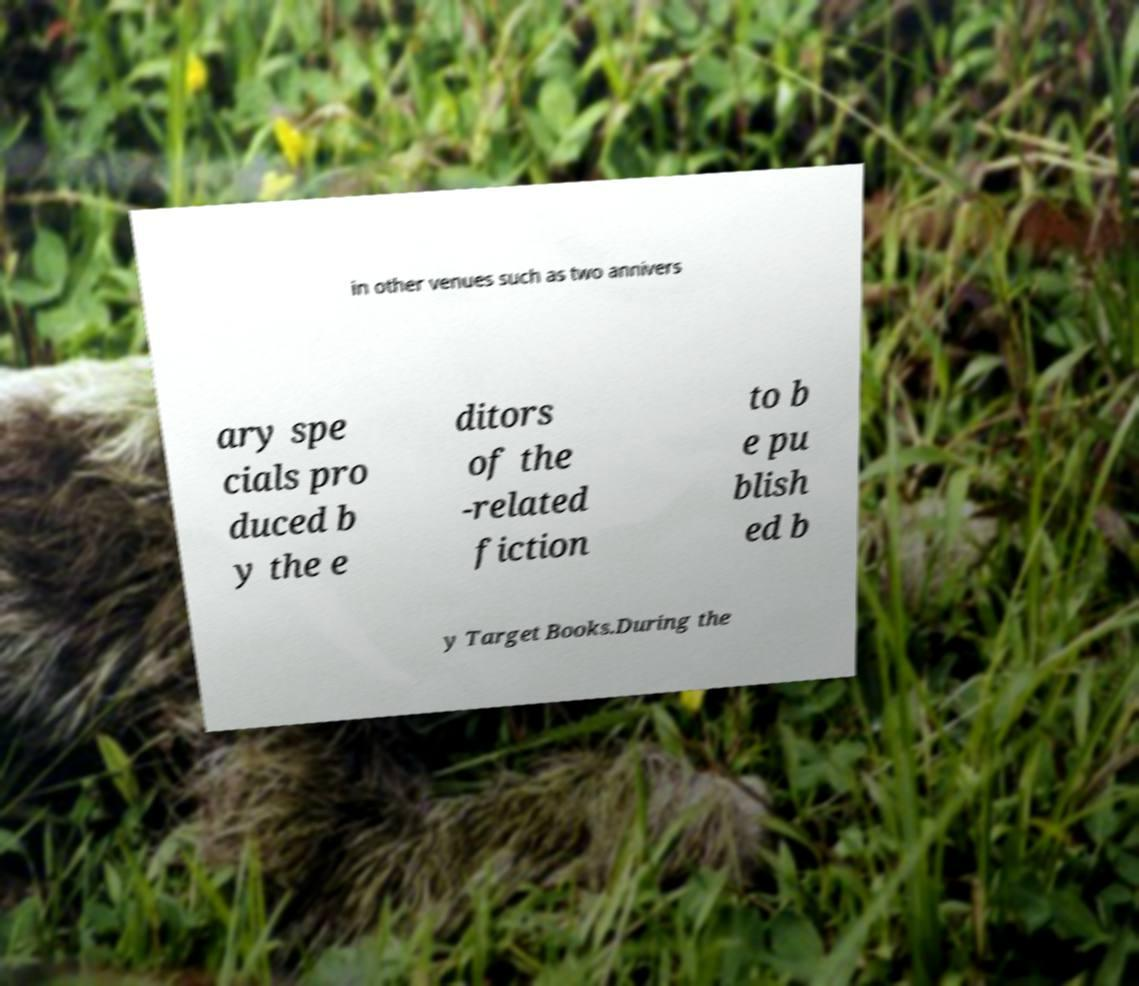Could you extract and type out the text from this image? in other venues such as two annivers ary spe cials pro duced b y the e ditors of the -related fiction to b e pu blish ed b y Target Books.During the 